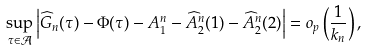Convert formula to latex. <formula><loc_0><loc_0><loc_500><loc_500>\sup _ { \tau \in \mathcal { A } } \left | \widehat { G } _ { n } ( \tau ) - \Phi ( \tau ) - A _ { 1 } ^ { n } - \widehat { A } _ { 2 } ^ { n } ( 1 ) - \widehat { A } _ { 2 } ^ { n } ( 2 ) \right | = o _ { p } \left ( \frac { 1 } { k _ { n } } \right ) ,</formula> 